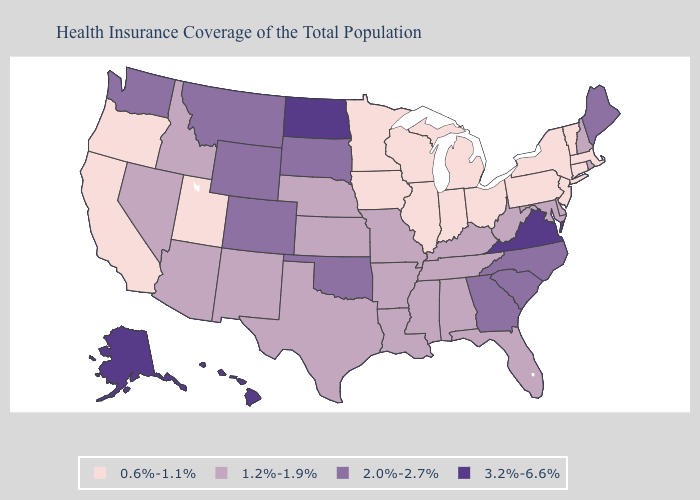Among the states that border Indiana , which have the lowest value?
Keep it brief. Illinois, Michigan, Ohio. Which states hav the highest value in the West?
Give a very brief answer. Alaska, Hawaii. What is the value of Georgia?
Keep it brief. 2.0%-2.7%. Name the states that have a value in the range 3.2%-6.6%?
Short answer required. Alaska, Hawaii, North Dakota, Virginia. Name the states that have a value in the range 3.2%-6.6%?
Concise answer only. Alaska, Hawaii, North Dakota, Virginia. What is the lowest value in the South?
Short answer required. 1.2%-1.9%. Name the states that have a value in the range 2.0%-2.7%?
Give a very brief answer. Colorado, Georgia, Maine, Montana, North Carolina, Oklahoma, South Carolina, South Dakota, Washington, Wyoming. What is the value of South Carolina?
Give a very brief answer. 2.0%-2.7%. What is the value of West Virginia?
Answer briefly. 1.2%-1.9%. Is the legend a continuous bar?
Give a very brief answer. No. Does the map have missing data?
Answer briefly. No. What is the value of South Carolina?
Be succinct. 2.0%-2.7%. What is the value of Iowa?
Concise answer only. 0.6%-1.1%. What is the highest value in the South ?
Give a very brief answer. 3.2%-6.6%. Among the states that border Montana , which have the lowest value?
Write a very short answer. Idaho. 